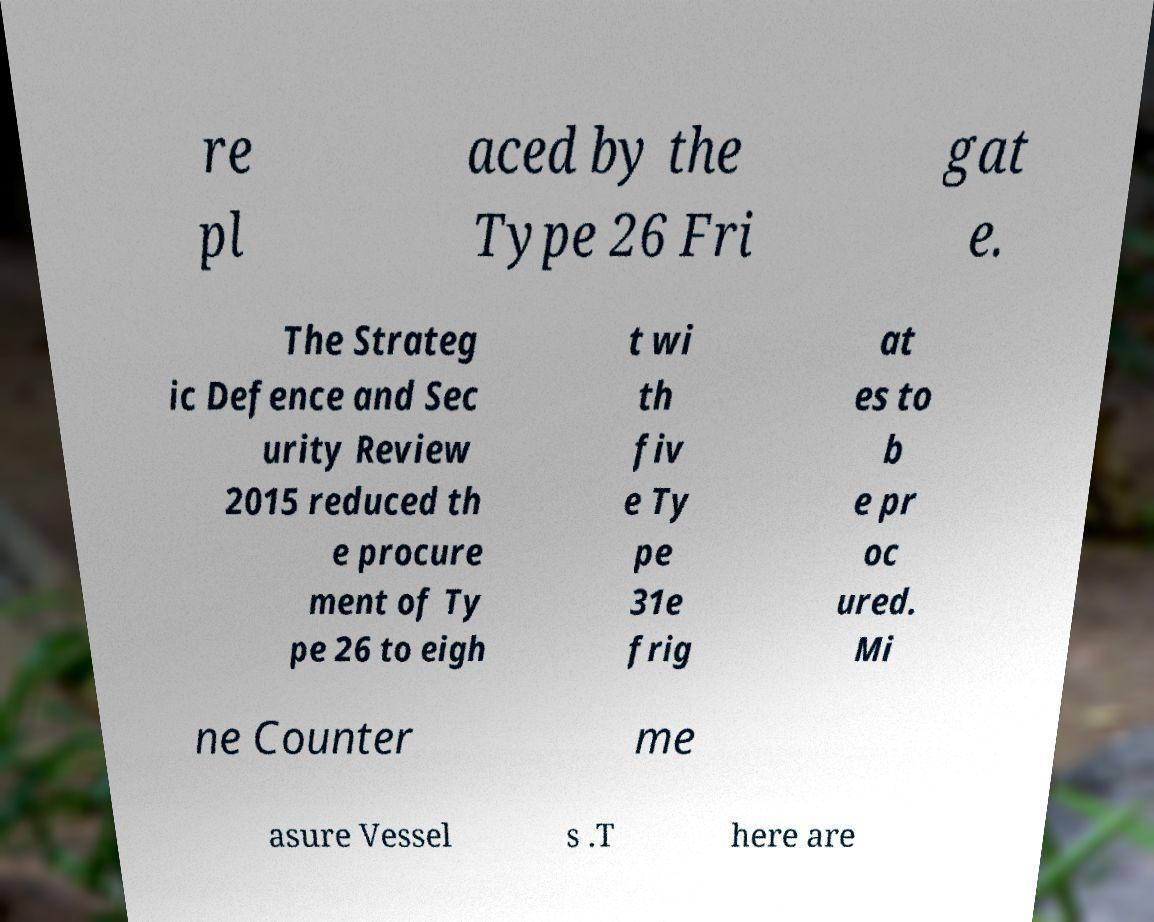For documentation purposes, I need the text within this image transcribed. Could you provide that? re pl aced by the Type 26 Fri gat e. The Strateg ic Defence and Sec urity Review 2015 reduced th e procure ment of Ty pe 26 to eigh t wi th fiv e Ty pe 31e frig at es to b e pr oc ured. Mi ne Counter me asure Vessel s .T here are 